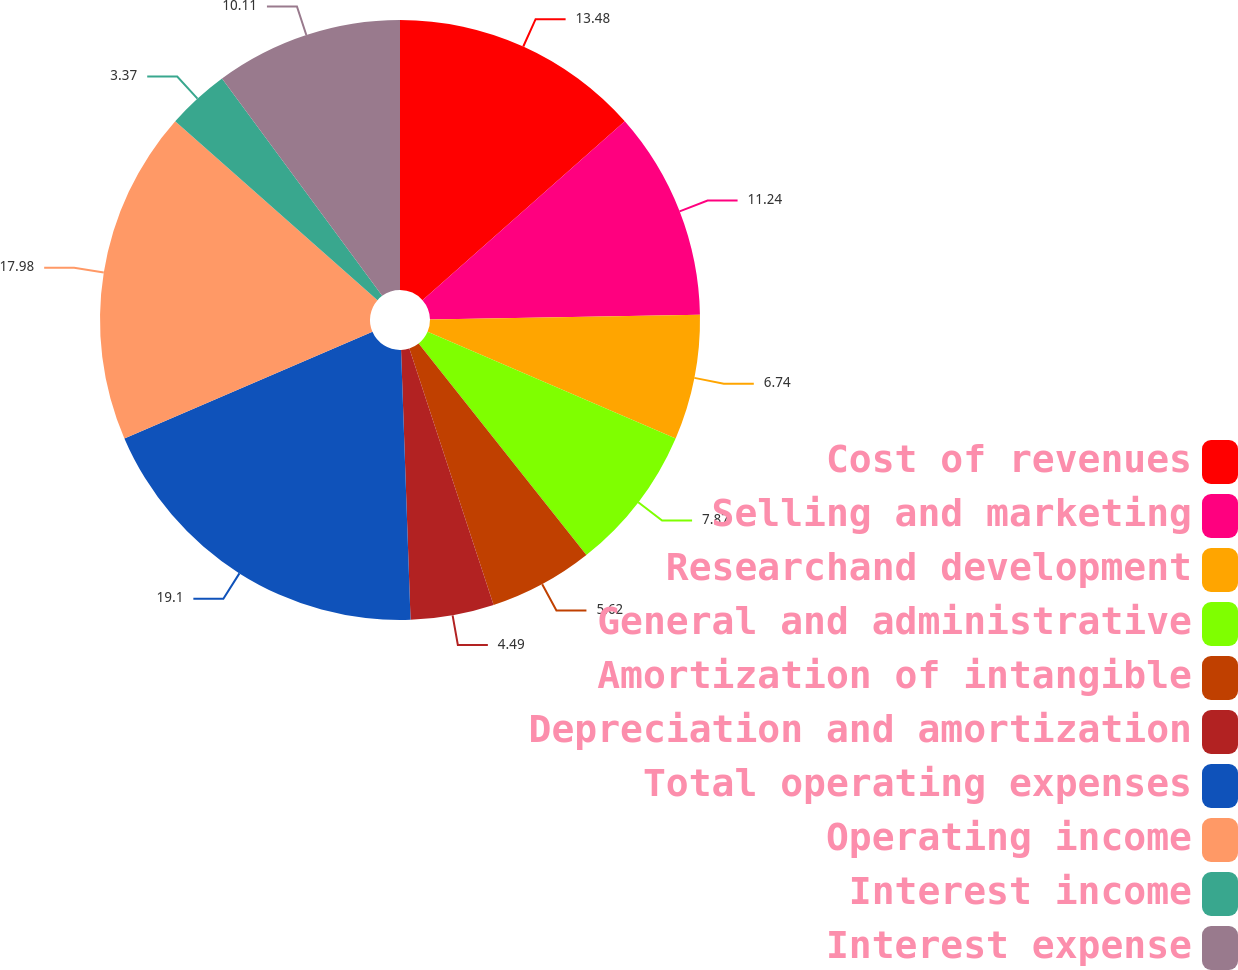Convert chart to OTSL. <chart><loc_0><loc_0><loc_500><loc_500><pie_chart><fcel>Cost of revenues<fcel>Selling and marketing<fcel>Researchand development<fcel>General and administrative<fcel>Amortization of intangible<fcel>Depreciation and amortization<fcel>Total operating expenses<fcel>Operating income<fcel>Interest income<fcel>Interest expense<nl><fcel>13.48%<fcel>11.24%<fcel>6.74%<fcel>7.87%<fcel>5.62%<fcel>4.49%<fcel>19.1%<fcel>17.98%<fcel>3.37%<fcel>10.11%<nl></chart> 